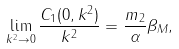<formula> <loc_0><loc_0><loc_500><loc_500>\lim _ { k ^ { 2 } \rightarrow 0 } \frac { C _ { 1 } ( 0 , k ^ { 2 } ) } { k ^ { 2 } } = \frac { m _ { 2 } } { \alpha } \beta _ { M } ,</formula> 